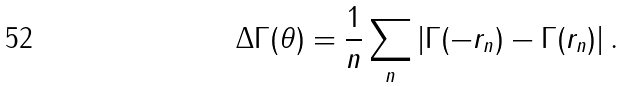Convert formula to latex. <formula><loc_0><loc_0><loc_500><loc_500>\Delta \Gamma ( \theta ) = \frac { 1 } { n } \sum _ { n } \left | \Gamma ( - r _ { n } ) - \Gamma ( r _ { n } ) \right | .</formula> 